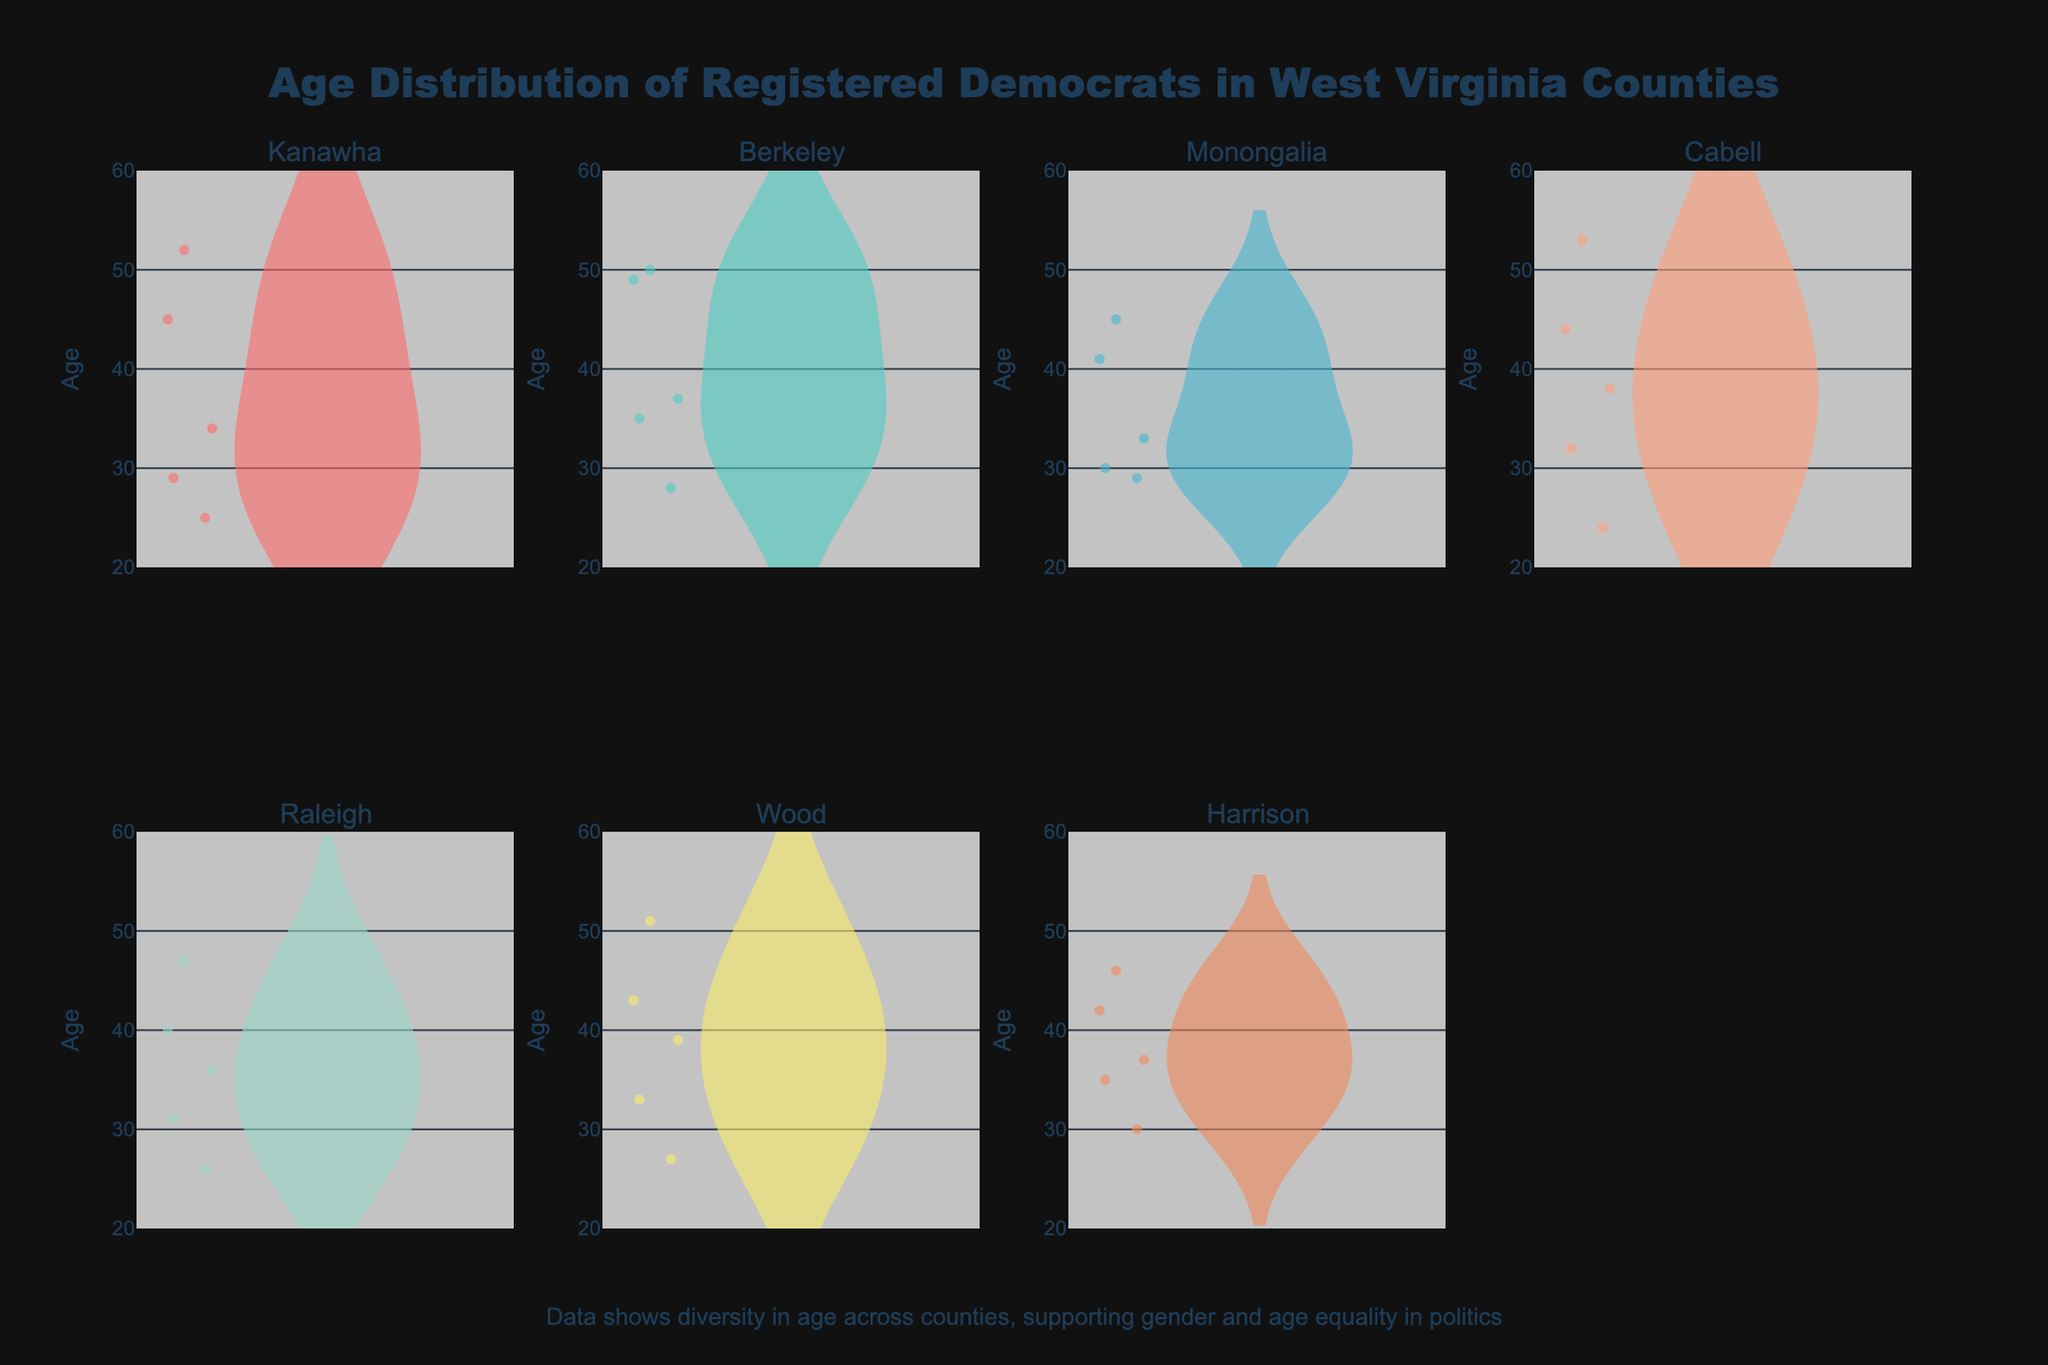What is the title of the figure? The title of the figure is displayed at the top and reads "Age Distribution of Registered Democrats in West Virginia Counties." This identifies the subject of the plot.
Answer: "Age Distribution of Registered Democrats in West Virginia Counties" Which county has an average age closest to 30? To find the county with an average age closest to 30, look at the centers of the box plots within each violin chart, which represent the mean lines. Monongalia and Kanawha appear to have mean lines around 30 years.
Answer: Monongalia Which county displays the widest range in age? To determine the widest age range, observe the span from the smallest to the largest age value in each violin plot. Kanawha shows the largest range from around age 25 to age 52.
Answer: Kanawha In which county do you observe the highest age recorded? Examine the topmost points in each violin plot. The highest age observed is 53, which is within the Cabell county plot.
Answer: Cabell How does the age distribution in Berkeley compare to Cabell? Compare the shape and spread of the Berkeley and Cabell violin plots. Berkeley shows a broader middle range, whereas Cabell shows a more evenly distributed age with denser concentration in the lower ages.
Answer: Berkeley shows a broader middle range, Cabell is more evenly distributed What is the youngest age recorded across all counties? Identify the lowest points on the y-axis of the violin plots. The youngest age recorded is 24 in Cabell county.
Answer: 24 Which county has the narrowest age range? A narrow age range will show as a shorter span on the y-axis in the violin plot. Monongalia displays the narrowest range, approximately from 29 to 45 years.
Answer: Monongalia Is there evidence of age diversity in Raleigh county? Assess the spread and shape of the Raleigh county violin plot. Raleigh displays a wide range of ages from 26 to 47, indicating diverse age distribution.
Answer: Yes How many counties have their upper age range touching 50 or above? Count the violin plots where the age data reaches or exceeds 50. These counties are Berkeley, Cabell, Harrison, Kanawha, and Wood.
Answer: 5 What kind of visual elements highlight age diversity in this plot? The spread of individual data points, box plots indicating median and quartiles, and violin shapes showing age density are visual elements that highlight age diversity.
Answer: Spread of points, box plots, density shapes 